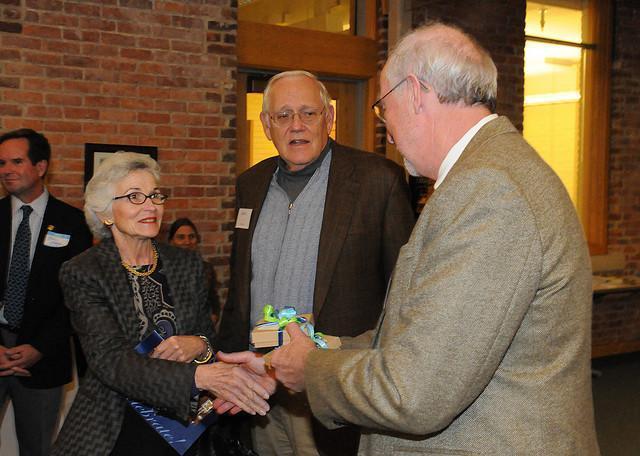How many people are there?
Give a very brief answer. 5. How many people can you see?
Give a very brief answer. 4. How many chairs have a checkered pattern?
Give a very brief answer. 0. 